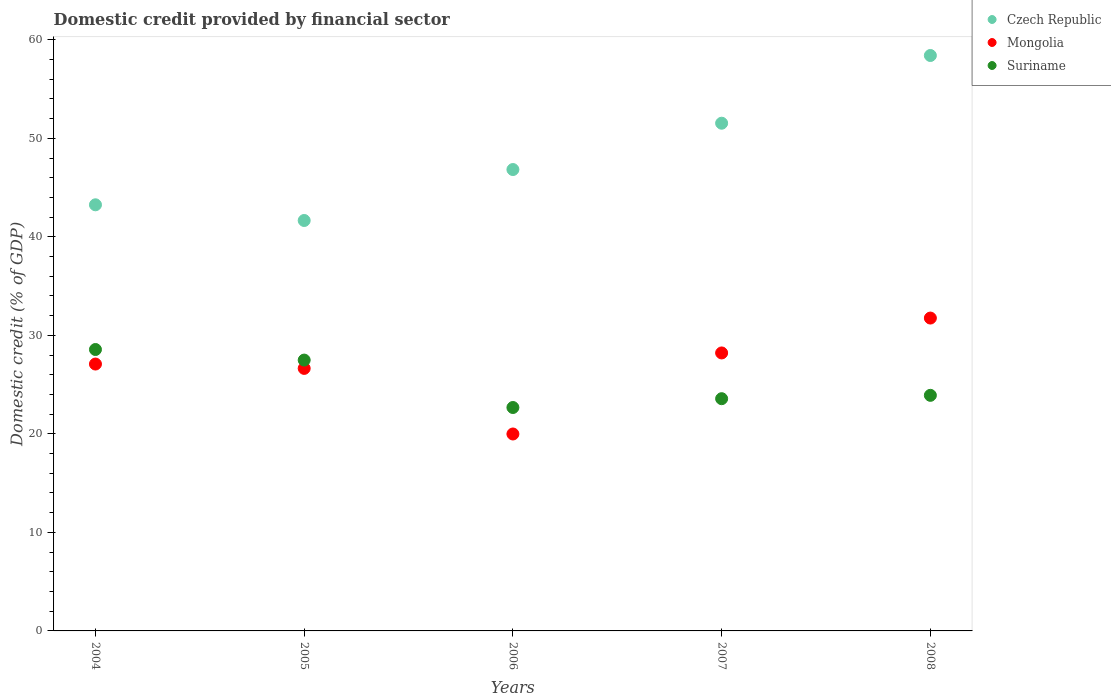How many different coloured dotlines are there?
Keep it short and to the point. 3. Is the number of dotlines equal to the number of legend labels?
Offer a terse response. Yes. What is the domestic credit in Suriname in 2007?
Offer a terse response. 23.57. Across all years, what is the maximum domestic credit in Suriname?
Offer a terse response. 28.56. Across all years, what is the minimum domestic credit in Czech Republic?
Offer a terse response. 41.66. In which year was the domestic credit in Mongolia minimum?
Provide a succinct answer. 2006. What is the total domestic credit in Suriname in the graph?
Offer a terse response. 126.21. What is the difference between the domestic credit in Mongolia in 2004 and that in 2008?
Keep it short and to the point. -4.67. What is the difference between the domestic credit in Mongolia in 2006 and the domestic credit in Czech Republic in 2008?
Your answer should be very brief. -38.42. What is the average domestic credit in Czech Republic per year?
Your answer should be very brief. 48.33. In the year 2004, what is the difference between the domestic credit in Mongolia and domestic credit in Czech Republic?
Offer a terse response. -16.16. What is the ratio of the domestic credit in Czech Republic in 2007 to that in 2008?
Your answer should be very brief. 0.88. Is the difference between the domestic credit in Mongolia in 2005 and 2007 greater than the difference between the domestic credit in Czech Republic in 2005 and 2007?
Ensure brevity in your answer.  Yes. What is the difference between the highest and the second highest domestic credit in Czech Republic?
Keep it short and to the point. 6.87. What is the difference between the highest and the lowest domestic credit in Suriname?
Offer a very short reply. 5.89. Is the sum of the domestic credit in Suriname in 2006 and 2007 greater than the maximum domestic credit in Mongolia across all years?
Provide a short and direct response. Yes. Is the domestic credit in Czech Republic strictly greater than the domestic credit in Suriname over the years?
Your answer should be very brief. Yes. Is the domestic credit in Mongolia strictly less than the domestic credit in Suriname over the years?
Your response must be concise. No. What is the difference between two consecutive major ticks on the Y-axis?
Offer a terse response. 10. Are the values on the major ticks of Y-axis written in scientific E-notation?
Your response must be concise. No. Does the graph contain any zero values?
Give a very brief answer. No. Does the graph contain grids?
Your response must be concise. No. How are the legend labels stacked?
Your response must be concise. Vertical. What is the title of the graph?
Your answer should be very brief. Domestic credit provided by financial sector. What is the label or title of the X-axis?
Provide a short and direct response. Years. What is the label or title of the Y-axis?
Offer a very short reply. Domestic credit (% of GDP). What is the Domestic credit (% of GDP) of Czech Republic in 2004?
Your answer should be compact. 43.25. What is the Domestic credit (% of GDP) in Mongolia in 2004?
Keep it short and to the point. 27.09. What is the Domestic credit (% of GDP) in Suriname in 2004?
Offer a very short reply. 28.56. What is the Domestic credit (% of GDP) in Czech Republic in 2005?
Give a very brief answer. 41.66. What is the Domestic credit (% of GDP) of Mongolia in 2005?
Give a very brief answer. 26.65. What is the Domestic credit (% of GDP) of Suriname in 2005?
Keep it short and to the point. 27.49. What is the Domestic credit (% of GDP) in Czech Republic in 2006?
Give a very brief answer. 46.83. What is the Domestic credit (% of GDP) of Mongolia in 2006?
Give a very brief answer. 19.99. What is the Domestic credit (% of GDP) in Suriname in 2006?
Offer a very short reply. 22.68. What is the Domestic credit (% of GDP) of Czech Republic in 2007?
Your answer should be very brief. 51.53. What is the Domestic credit (% of GDP) of Mongolia in 2007?
Ensure brevity in your answer.  28.21. What is the Domestic credit (% of GDP) of Suriname in 2007?
Your answer should be compact. 23.57. What is the Domestic credit (% of GDP) of Czech Republic in 2008?
Ensure brevity in your answer.  58.4. What is the Domestic credit (% of GDP) in Mongolia in 2008?
Give a very brief answer. 31.76. What is the Domestic credit (% of GDP) of Suriname in 2008?
Provide a succinct answer. 23.91. Across all years, what is the maximum Domestic credit (% of GDP) of Czech Republic?
Offer a terse response. 58.4. Across all years, what is the maximum Domestic credit (% of GDP) in Mongolia?
Make the answer very short. 31.76. Across all years, what is the maximum Domestic credit (% of GDP) of Suriname?
Keep it short and to the point. 28.56. Across all years, what is the minimum Domestic credit (% of GDP) in Czech Republic?
Provide a succinct answer. 41.66. Across all years, what is the minimum Domestic credit (% of GDP) in Mongolia?
Your response must be concise. 19.99. Across all years, what is the minimum Domestic credit (% of GDP) in Suriname?
Give a very brief answer. 22.68. What is the total Domestic credit (% of GDP) of Czech Republic in the graph?
Ensure brevity in your answer.  241.67. What is the total Domestic credit (% of GDP) of Mongolia in the graph?
Make the answer very short. 133.69. What is the total Domestic credit (% of GDP) in Suriname in the graph?
Make the answer very short. 126.21. What is the difference between the Domestic credit (% of GDP) of Czech Republic in 2004 and that in 2005?
Make the answer very short. 1.59. What is the difference between the Domestic credit (% of GDP) in Mongolia in 2004 and that in 2005?
Your answer should be compact. 0.44. What is the difference between the Domestic credit (% of GDP) of Suriname in 2004 and that in 2005?
Give a very brief answer. 1.07. What is the difference between the Domestic credit (% of GDP) of Czech Republic in 2004 and that in 2006?
Make the answer very short. -3.58. What is the difference between the Domestic credit (% of GDP) of Mongolia in 2004 and that in 2006?
Your answer should be very brief. 7.1. What is the difference between the Domestic credit (% of GDP) in Suriname in 2004 and that in 2006?
Offer a terse response. 5.89. What is the difference between the Domestic credit (% of GDP) in Czech Republic in 2004 and that in 2007?
Make the answer very short. -8.28. What is the difference between the Domestic credit (% of GDP) of Mongolia in 2004 and that in 2007?
Your response must be concise. -1.13. What is the difference between the Domestic credit (% of GDP) of Suriname in 2004 and that in 2007?
Give a very brief answer. 4.99. What is the difference between the Domestic credit (% of GDP) of Czech Republic in 2004 and that in 2008?
Your answer should be very brief. -15.15. What is the difference between the Domestic credit (% of GDP) of Mongolia in 2004 and that in 2008?
Offer a terse response. -4.67. What is the difference between the Domestic credit (% of GDP) of Suriname in 2004 and that in 2008?
Keep it short and to the point. 4.65. What is the difference between the Domestic credit (% of GDP) of Czech Republic in 2005 and that in 2006?
Offer a terse response. -5.17. What is the difference between the Domestic credit (% of GDP) in Mongolia in 2005 and that in 2006?
Provide a succinct answer. 6.66. What is the difference between the Domestic credit (% of GDP) in Suriname in 2005 and that in 2006?
Your answer should be compact. 4.81. What is the difference between the Domestic credit (% of GDP) of Czech Republic in 2005 and that in 2007?
Make the answer very short. -9.87. What is the difference between the Domestic credit (% of GDP) in Mongolia in 2005 and that in 2007?
Offer a terse response. -1.57. What is the difference between the Domestic credit (% of GDP) of Suriname in 2005 and that in 2007?
Your answer should be very brief. 3.92. What is the difference between the Domestic credit (% of GDP) of Czech Republic in 2005 and that in 2008?
Offer a very short reply. -16.75. What is the difference between the Domestic credit (% of GDP) of Mongolia in 2005 and that in 2008?
Your response must be concise. -5.11. What is the difference between the Domestic credit (% of GDP) of Suriname in 2005 and that in 2008?
Give a very brief answer. 3.58. What is the difference between the Domestic credit (% of GDP) of Czech Republic in 2006 and that in 2007?
Give a very brief answer. -4.7. What is the difference between the Domestic credit (% of GDP) in Mongolia in 2006 and that in 2007?
Provide a short and direct response. -8.23. What is the difference between the Domestic credit (% of GDP) in Suriname in 2006 and that in 2007?
Provide a short and direct response. -0.89. What is the difference between the Domestic credit (% of GDP) in Czech Republic in 2006 and that in 2008?
Your answer should be compact. -11.57. What is the difference between the Domestic credit (% of GDP) of Mongolia in 2006 and that in 2008?
Offer a terse response. -11.77. What is the difference between the Domestic credit (% of GDP) in Suriname in 2006 and that in 2008?
Keep it short and to the point. -1.24. What is the difference between the Domestic credit (% of GDP) of Czech Republic in 2007 and that in 2008?
Offer a terse response. -6.87. What is the difference between the Domestic credit (% of GDP) of Mongolia in 2007 and that in 2008?
Provide a succinct answer. -3.54. What is the difference between the Domestic credit (% of GDP) of Suriname in 2007 and that in 2008?
Keep it short and to the point. -0.34. What is the difference between the Domestic credit (% of GDP) in Czech Republic in 2004 and the Domestic credit (% of GDP) in Mongolia in 2005?
Offer a very short reply. 16.6. What is the difference between the Domestic credit (% of GDP) of Czech Republic in 2004 and the Domestic credit (% of GDP) of Suriname in 2005?
Make the answer very short. 15.76. What is the difference between the Domestic credit (% of GDP) in Mongolia in 2004 and the Domestic credit (% of GDP) in Suriname in 2005?
Provide a short and direct response. -0.4. What is the difference between the Domestic credit (% of GDP) of Czech Republic in 2004 and the Domestic credit (% of GDP) of Mongolia in 2006?
Ensure brevity in your answer.  23.26. What is the difference between the Domestic credit (% of GDP) in Czech Republic in 2004 and the Domestic credit (% of GDP) in Suriname in 2006?
Provide a short and direct response. 20.57. What is the difference between the Domestic credit (% of GDP) of Mongolia in 2004 and the Domestic credit (% of GDP) of Suriname in 2006?
Your answer should be compact. 4.41. What is the difference between the Domestic credit (% of GDP) in Czech Republic in 2004 and the Domestic credit (% of GDP) in Mongolia in 2007?
Give a very brief answer. 15.04. What is the difference between the Domestic credit (% of GDP) in Czech Republic in 2004 and the Domestic credit (% of GDP) in Suriname in 2007?
Give a very brief answer. 19.68. What is the difference between the Domestic credit (% of GDP) in Mongolia in 2004 and the Domestic credit (% of GDP) in Suriname in 2007?
Offer a terse response. 3.52. What is the difference between the Domestic credit (% of GDP) in Czech Republic in 2004 and the Domestic credit (% of GDP) in Mongolia in 2008?
Provide a short and direct response. 11.5. What is the difference between the Domestic credit (% of GDP) of Czech Republic in 2004 and the Domestic credit (% of GDP) of Suriname in 2008?
Your answer should be very brief. 19.34. What is the difference between the Domestic credit (% of GDP) of Mongolia in 2004 and the Domestic credit (% of GDP) of Suriname in 2008?
Make the answer very short. 3.18. What is the difference between the Domestic credit (% of GDP) in Czech Republic in 2005 and the Domestic credit (% of GDP) in Mongolia in 2006?
Provide a short and direct response. 21.67. What is the difference between the Domestic credit (% of GDP) of Czech Republic in 2005 and the Domestic credit (% of GDP) of Suriname in 2006?
Give a very brief answer. 18.98. What is the difference between the Domestic credit (% of GDP) of Mongolia in 2005 and the Domestic credit (% of GDP) of Suriname in 2006?
Offer a very short reply. 3.97. What is the difference between the Domestic credit (% of GDP) of Czech Republic in 2005 and the Domestic credit (% of GDP) of Mongolia in 2007?
Ensure brevity in your answer.  13.44. What is the difference between the Domestic credit (% of GDP) in Czech Republic in 2005 and the Domestic credit (% of GDP) in Suriname in 2007?
Your answer should be compact. 18.09. What is the difference between the Domestic credit (% of GDP) in Mongolia in 2005 and the Domestic credit (% of GDP) in Suriname in 2007?
Your answer should be compact. 3.07. What is the difference between the Domestic credit (% of GDP) of Czech Republic in 2005 and the Domestic credit (% of GDP) of Mongolia in 2008?
Offer a very short reply. 9.9. What is the difference between the Domestic credit (% of GDP) of Czech Republic in 2005 and the Domestic credit (% of GDP) of Suriname in 2008?
Your answer should be compact. 17.75. What is the difference between the Domestic credit (% of GDP) of Mongolia in 2005 and the Domestic credit (% of GDP) of Suriname in 2008?
Offer a very short reply. 2.73. What is the difference between the Domestic credit (% of GDP) in Czech Republic in 2006 and the Domestic credit (% of GDP) in Mongolia in 2007?
Offer a terse response. 18.62. What is the difference between the Domestic credit (% of GDP) in Czech Republic in 2006 and the Domestic credit (% of GDP) in Suriname in 2007?
Provide a short and direct response. 23.26. What is the difference between the Domestic credit (% of GDP) in Mongolia in 2006 and the Domestic credit (% of GDP) in Suriname in 2007?
Keep it short and to the point. -3.58. What is the difference between the Domestic credit (% of GDP) in Czech Republic in 2006 and the Domestic credit (% of GDP) in Mongolia in 2008?
Provide a succinct answer. 15.07. What is the difference between the Domestic credit (% of GDP) of Czech Republic in 2006 and the Domestic credit (% of GDP) of Suriname in 2008?
Your answer should be very brief. 22.92. What is the difference between the Domestic credit (% of GDP) in Mongolia in 2006 and the Domestic credit (% of GDP) in Suriname in 2008?
Provide a short and direct response. -3.92. What is the difference between the Domestic credit (% of GDP) in Czech Republic in 2007 and the Domestic credit (% of GDP) in Mongolia in 2008?
Your response must be concise. 19.78. What is the difference between the Domestic credit (% of GDP) in Czech Republic in 2007 and the Domestic credit (% of GDP) in Suriname in 2008?
Your answer should be very brief. 27.62. What is the difference between the Domestic credit (% of GDP) in Mongolia in 2007 and the Domestic credit (% of GDP) in Suriname in 2008?
Offer a terse response. 4.3. What is the average Domestic credit (% of GDP) in Czech Republic per year?
Your answer should be compact. 48.34. What is the average Domestic credit (% of GDP) in Mongolia per year?
Offer a very short reply. 26.74. What is the average Domestic credit (% of GDP) of Suriname per year?
Your answer should be very brief. 25.24. In the year 2004, what is the difference between the Domestic credit (% of GDP) of Czech Republic and Domestic credit (% of GDP) of Mongolia?
Ensure brevity in your answer.  16.16. In the year 2004, what is the difference between the Domestic credit (% of GDP) in Czech Republic and Domestic credit (% of GDP) in Suriname?
Provide a succinct answer. 14.69. In the year 2004, what is the difference between the Domestic credit (% of GDP) in Mongolia and Domestic credit (% of GDP) in Suriname?
Make the answer very short. -1.48. In the year 2005, what is the difference between the Domestic credit (% of GDP) of Czech Republic and Domestic credit (% of GDP) of Mongolia?
Provide a succinct answer. 15.01. In the year 2005, what is the difference between the Domestic credit (% of GDP) in Czech Republic and Domestic credit (% of GDP) in Suriname?
Keep it short and to the point. 14.17. In the year 2005, what is the difference between the Domestic credit (% of GDP) of Mongolia and Domestic credit (% of GDP) of Suriname?
Your answer should be compact. -0.84. In the year 2006, what is the difference between the Domestic credit (% of GDP) of Czech Republic and Domestic credit (% of GDP) of Mongolia?
Provide a succinct answer. 26.84. In the year 2006, what is the difference between the Domestic credit (% of GDP) in Czech Republic and Domestic credit (% of GDP) in Suriname?
Ensure brevity in your answer.  24.15. In the year 2006, what is the difference between the Domestic credit (% of GDP) in Mongolia and Domestic credit (% of GDP) in Suriname?
Provide a succinct answer. -2.69. In the year 2007, what is the difference between the Domestic credit (% of GDP) of Czech Republic and Domestic credit (% of GDP) of Mongolia?
Give a very brief answer. 23.32. In the year 2007, what is the difference between the Domestic credit (% of GDP) in Czech Republic and Domestic credit (% of GDP) in Suriname?
Your answer should be very brief. 27.96. In the year 2007, what is the difference between the Domestic credit (% of GDP) of Mongolia and Domestic credit (% of GDP) of Suriname?
Provide a short and direct response. 4.64. In the year 2008, what is the difference between the Domestic credit (% of GDP) in Czech Republic and Domestic credit (% of GDP) in Mongolia?
Provide a succinct answer. 26.65. In the year 2008, what is the difference between the Domestic credit (% of GDP) in Czech Republic and Domestic credit (% of GDP) in Suriname?
Provide a short and direct response. 34.49. In the year 2008, what is the difference between the Domestic credit (% of GDP) in Mongolia and Domestic credit (% of GDP) in Suriname?
Your response must be concise. 7.84. What is the ratio of the Domestic credit (% of GDP) in Czech Republic in 2004 to that in 2005?
Provide a short and direct response. 1.04. What is the ratio of the Domestic credit (% of GDP) of Mongolia in 2004 to that in 2005?
Keep it short and to the point. 1.02. What is the ratio of the Domestic credit (% of GDP) of Suriname in 2004 to that in 2005?
Provide a succinct answer. 1.04. What is the ratio of the Domestic credit (% of GDP) in Czech Republic in 2004 to that in 2006?
Your answer should be very brief. 0.92. What is the ratio of the Domestic credit (% of GDP) of Mongolia in 2004 to that in 2006?
Your answer should be compact. 1.36. What is the ratio of the Domestic credit (% of GDP) of Suriname in 2004 to that in 2006?
Offer a terse response. 1.26. What is the ratio of the Domestic credit (% of GDP) in Czech Republic in 2004 to that in 2007?
Your answer should be very brief. 0.84. What is the ratio of the Domestic credit (% of GDP) in Mongolia in 2004 to that in 2007?
Your answer should be compact. 0.96. What is the ratio of the Domestic credit (% of GDP) in Suriname in 2004 to that in 2007?
Make the answer very short. 1.21. What is the ratio of the Domestic credit (% of GDP) in Czech Republic in 2004 to that in 2008?
Give a very brief answer. 0.74. What is the ratio of the Domestic credit (% of GDP) of Mongolia in 2004 to that in 2008?
Provide a succinct answer. 0.85. What is the ratio of the Domestic credit (% of GDP) in Suriname in 2004 to that in 2008?
Provide a succinct answer. 1.19. What is the ratio of the Domestic credit (% of GDP) of Czech Republic in 2005 to that in 2006?
Offer a very short reply. 0.89. What is the ratio of the Domestic credit (% of GDP) in Mongolia in 2005 to that in 2006?
Your answer should be very brief. 1.33. What is the ratio of the Domestic credit (% of GDP) of Suriname in 2005 to that in 2006?
Your response must be concise. 1.21. What is the ratio of the Domestic credit (% of GDP) in Czech Republic in 2005 to that in 2007?
Offer a very short reply. 0.81. What is the ratio of the Domestic credit (% of GDP) in Mongolia in 2005 to that in 2007?
Give a very brief answer. 0.94. What is the ratio of the Domestic credit (% of GDP) of Suriname in 2005 to that in 2007?
Provide a short and direct response. 1.17. What is the ratio of the Domestic credit (% of GDP) of Czech Republic in 2005 to that in 2008?
Make the answer very short. 0.71. What is the ratio of the Domestic credit (% of GDP) in Mongolia in 2005 to that in 2008?
Keep it short and to the point. 0.84. What is the ratio of the Domestic credit (% of GDP) of Suriname in 2005 to that in 2008?
Your answer should be very brief. 1.15. What is the ratio of the Domestic credit (% of GDP) in Czech Republic in 2006 to that in 2007?
Keep it short and to the point. 0.91. What is the ratio of the Domestic credit (% of GDP) in Mongolia in 2006 to that in 2007?
Give a very brief answer. 0.71. What is the ratio of the Domestic credit (% of GDP) in Suriname in 2006 to that in 2007?
Your answer should be very brief. 0.96. What is the ratio of the Domestic credit (% of GDP) of Czech Republic in 2006 to that in 2008?
Provide a succinct answer. 0.8. What is the ratio of the Domestic credit (% of GDP) of Mongolia in 2006 to that in 2008?
Your answer should be very brief. 0.63. What is the ratio of the Domestic credit (% of GDP) of Suriname in 2006 to that in 2008?
Your answer should be very brief. 0.95. What is the ratio of the Domestic credit (% of GDP) of Czech Republic in 2007 to that in 2008?
Give a very brief answer. 0.88. What is the ratio of the Domestic credit (% of GDP) of Mongolia in 2007 to that in 2008?
Give a very brief answer. 0.89. What is the ratio of the Domestic credit (% of GDP) in Suriname in 2007 to that in 2008?
Provide a short and direct response. 0.99. What is the difference between the highest and the second highest Domestic credit (% of GDP) in Czech Republic?
Provide a succinct answer. 6.87. What is the difference between the highest and the second highest Domestic credit (% of GDP) in Mongolia?
Keep it short and to the point. 3.54. What is the difference between the highest and the second highest Domestic credit (% of GDP) of Suriname?
Make the answer very short. 1.07. What is the difference between the highest and the lowest Domestic credit (% of GDP) of Czech Republic?
Provide a short and direct response. 16.75. What is the difference between the highest and the lowest Domestic credit (% of GDP) of Mongolia?
Provide a succinct answer. 11.77. What is the difference between the highest and the lowest Domestic credit (% of GDP) of Suriname?
Provide a short and direct response. 5.89. 